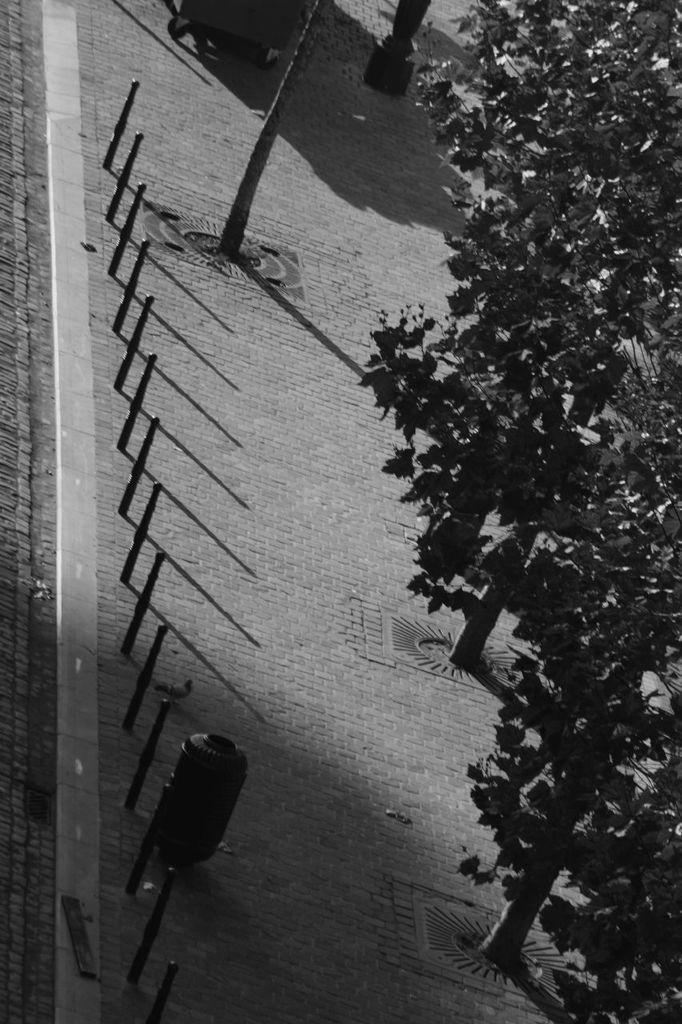In one or two sentences, can you explain what this image depicts? In this picture we can see trees on the right side, there is a pole here. 